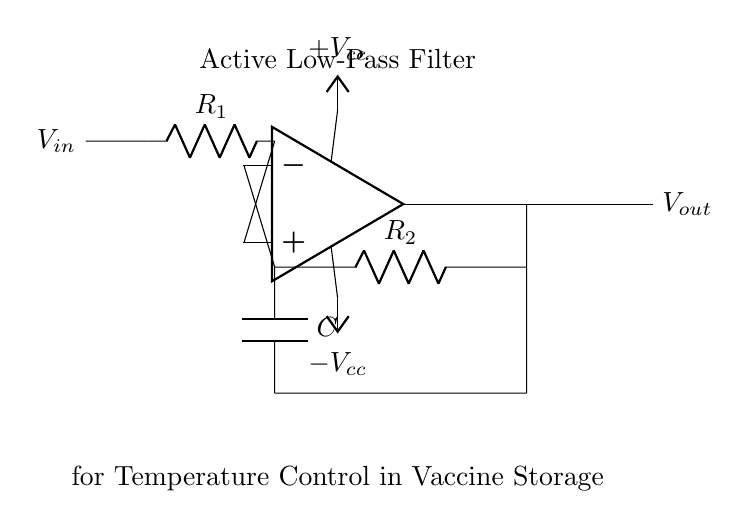What is the type of filter represented in this circuit? The circuit diagram clearly labels itself as an "Active Low-Pass Filter" at the top. This indicates the specific function of the filter in allowing low frequency signals to pass while attenuating high frequency signals.
Answer: Active Low-Pass Filter What components are present in the circuit? Identifying the components, we see an operational amplifier, two resistors labeled R1 and R2, and a capacitor labeled C. These are standard components used in analog filters.
Answer: Operational amplifier, resistors, capacitor What is the role of the operational amplifier in this circuit? The operational amplifier is crucial in maintaining desired signal levels and amplification in the filter. It controls the output based on the feedback from the resistors and the capacitor, allowing for precise filtering.
Answer: Amplification What is the value of the feedback resistor in this circuit? The feedback resistor is labeled as R2 in the diagram, and this designation signifies its function as part of the feedback loop that determines the gain of the operational amplifier in the circuit.
Answer: R2 How does the capacitor impact the filtration process? The capacitor, labeled C, affects the timing of the circuit's response to changes in the input voltage. It stores charge and influences the frequency response, contributing to the low-pass characteristic by allowing lower frequencies to pass while blocking higher frequencies.
Answer: Frequency response What is the relationship between R1 and R2 in controlling the output voltage? The output voltage is influenced by the ratio of R1 to R2, as both resistors determine the gain of the operational amplifier configured in this active filter. This feedback configuration sets the cutoff frequency and amplification factor.
Answer: Gain and cutoff frequency What is the significance of the power supply connections in this circuit? The power supply connections, labeled as +Vcc and -Vcc, provide the necessary supply voltages for the operational amplifier to function correctly. These supplies enable the op-amp to amplify the input signal properly, which is critical for the filter's operation.
Answer: Power supply voltages 